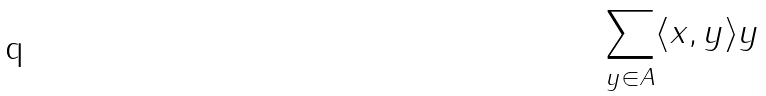<formula> <loc_0><loc_0><loc_500><loc_500>\sum _ { y \in A } \langle x , y \rangle y</formula> 